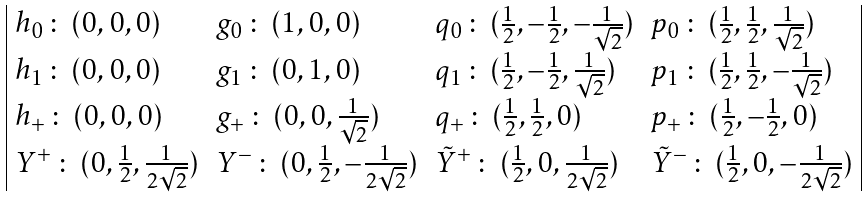Convert formula to latex. <formula><loc_0><loc_0><loc_500><loc_500>\begin{array} { | l l l l | } h _ { 0 } \, \colon \, ( 0 , 0 , 0 ) & g _ { 0 } \, \colon \, ( 1 , 0 , 0 ) & q _ { 0 } \, \colon \, ( \frac { 1 } { 2 } , - \frac { 1 } { 2 } , - \frac { 1 } { \sqrt { 2 } } ) & p _ { 0 } \, \colon \, ( \frac { 1 } { 2 } , \frac { 1 } { 2 } , \frac { 1 } { \sqrt { 2 } } ) \\ h _ { 1 } \, \colon \, ( 0 , 0 , 0 ) & g _ { 1 } \, \colon \, ( 0 , 1 , 0 ) & q _ { 1 } \, \colon \, ( \frac { 1 } { 2 } , - \frac { 1 } { 2 } , \frac { 1 } { \sqrt { 2 } } ) & p _ { 1 } \, \colon \, ( \frac { 1 } { 2 } , \frac { 1 } { 2 } , - \frac { 1 } { \sqrt { 2 } } ) \\ h _ { + } \, \colon \, ( 0 , 0 , 0 ) & g _ { + } \, \colon \, ( 0 , 0 , \frac { 1 } { \sqrt { 2 } } ) & q _ { + } \, \colon \, ( \frac { 1 } { 2 } , \frac { 1 } { 2 } , 0 ) & p _ { + } \, \colon \, ( \frac { 1 } { 2 } , - \frac { 1 } { 2 } , 0 ) \\ Y ^ { + } \, \colon \, ( 0 , \frac { 1 } { 2 } , \frac { 1 } { 2 \sqrt { 2 } } ) & Y ^ { - } \, \colon \, ( 0 , \frac { 1 } { 2 } , - \frac { 1 } { 2 \sqrt { 2 } } ) & \tilde { Y } ^ { + } \, \colon \, ( \frac { 1 } { 2 } , 0 , \frac { 1 } { 2 \sqrt { 2 } } ) & \tilde { Y } ^ { - } \, \colon \, ( \frac { 1 } { 2 } , 0 , - \frac { 1 } { 2 \sqrt { 2 } } ) \\ \end{array}</formula> 